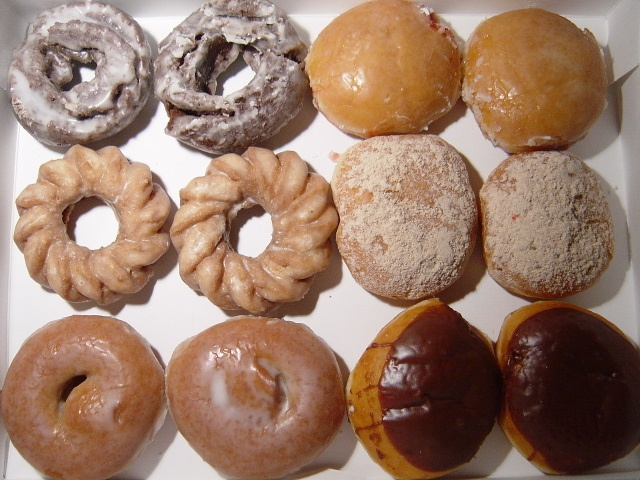Describe the objects in this image and their specific colors. I can see donut in gray, brown, salmon, and maroon tones, donut in gray and tan tones, donut in gray, brown, and tan tones, donut in gray, black, maroon, and brown tones, and donut in gray and tan tones in this image. 